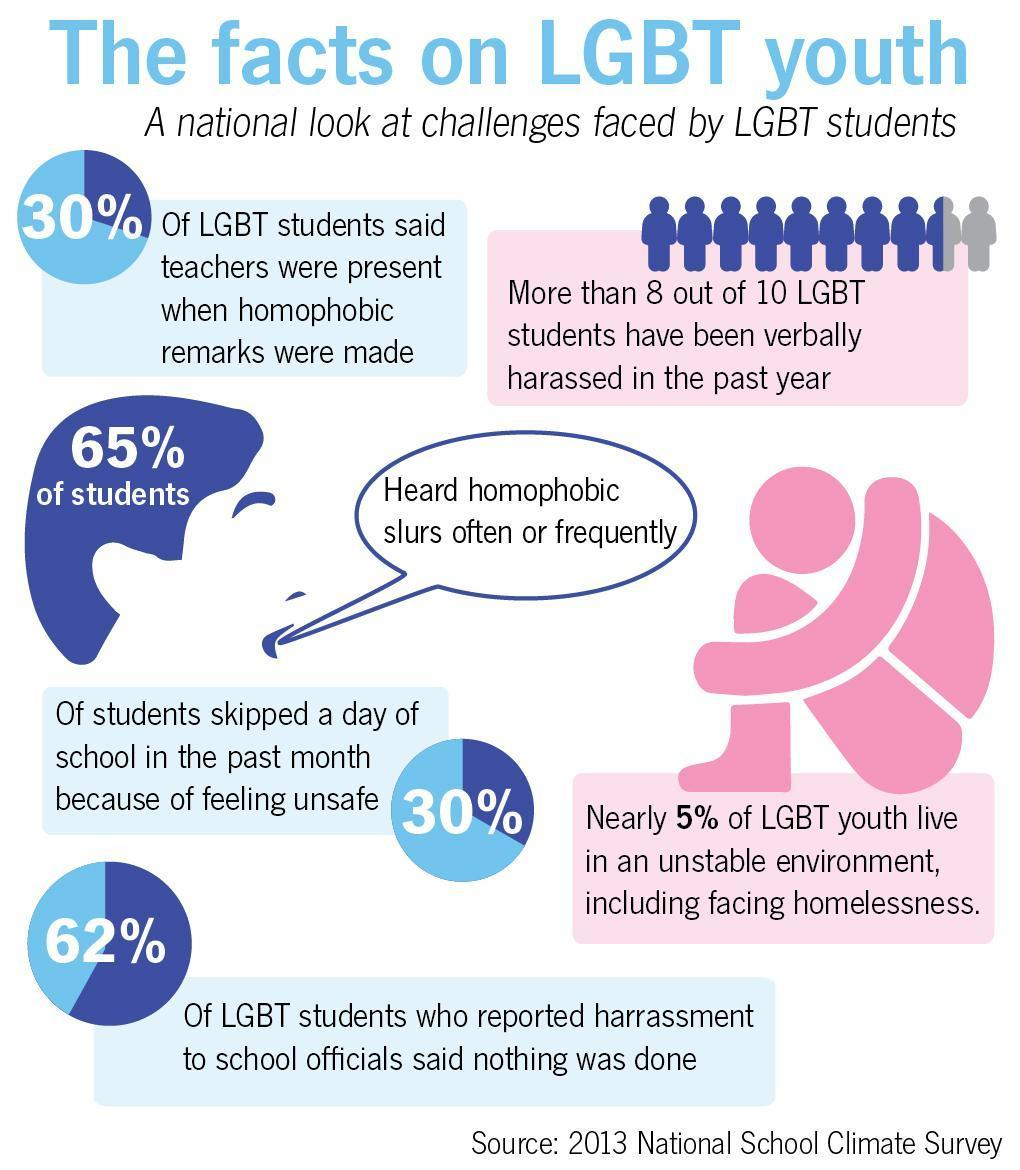What remarks were made against LGBT students?
Answer the question with a short phrase. homophobic What percentage of the students skipped school? 30% Inaction by school authorities was mentioned in how many of the cases? 62% 